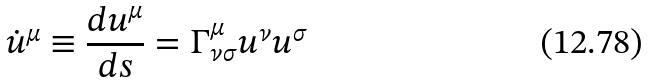Convert formula to latex. <formula><loc_0><loc_0><loc_500><loc_500>\dot { u } ^ { \mu } \equiv \frac { d u ^ { \mu } } { d s } = \Gamma ^ { \mu } _ { \nu \sigma } u ^ { \nu } u ^ { \sigma }</formula> 